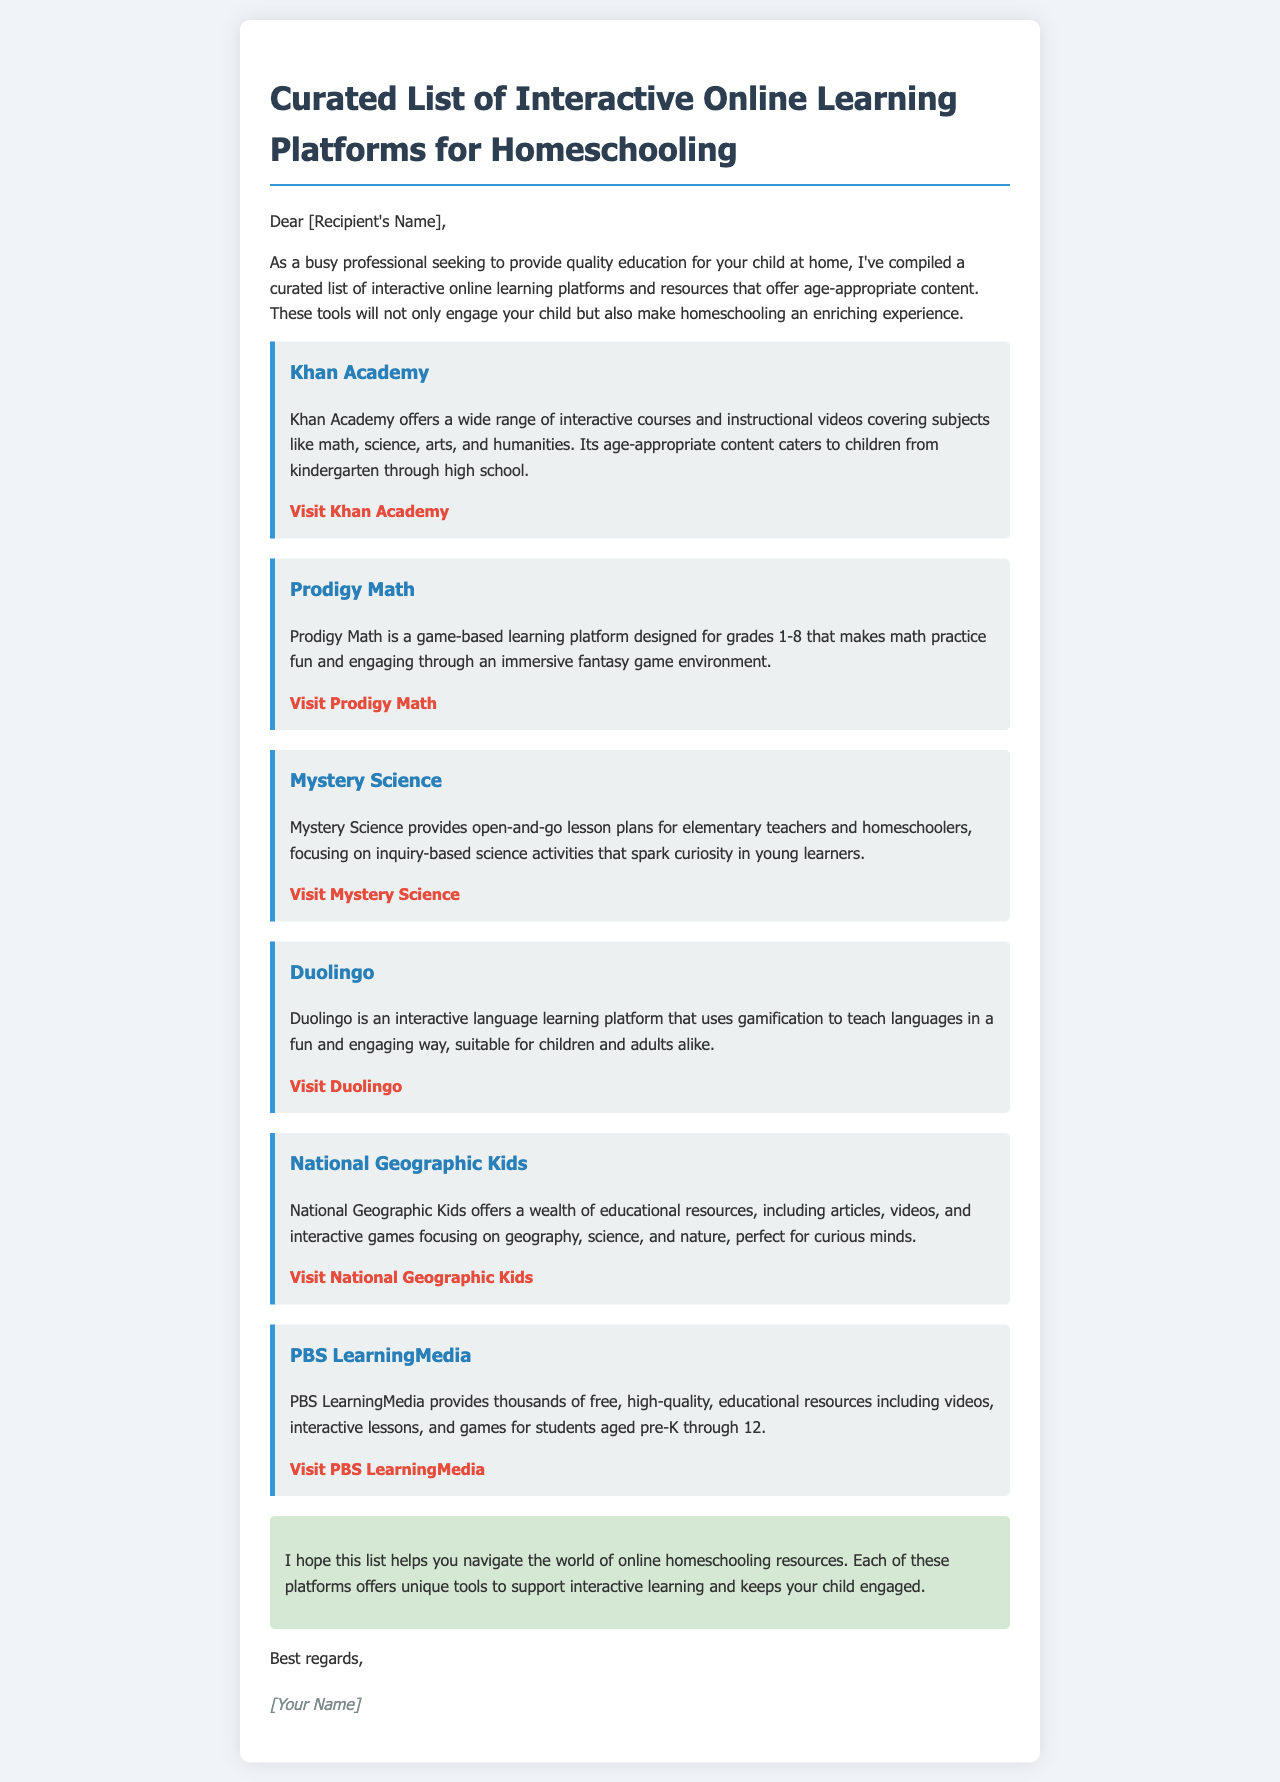What is the title of the document? The title of the document is found in the header section, which presents the main topic of the email.
Answer: Interactive Online Learning Platforms for Homeschooling How many online learning platforms are listed? The document contains six different online learning platforms and resources for homeschooling.
Answer: 6 What is the website for Khan Academy? The website provided for Khan Academy can be found in the resource section related to it.
Answer: https://www.khanacademy.org Which platform is focused on game-based learning? The document specifically mentions one platform that emphasizes a game-based learning approach for math.
Answer: Prodigy Math What age group does Mystery Science cater to? The document states that Mystery Science is specifically designed for elementary teachers and homeschoolers, indicating the educational level it targets.
Answer: Elementary Which platform uses gamification for language learning? The document identifies a specific platform that employs gamification as a method for teaching languages.
Answer: Duolingo What type of resources does PBS LearningMedia provide? The email outlines the types of materials available on PBS LearningMedia, describing them in broad categories.
Answer: Educational resources What is the main purpose of the email? The main purpose of the email is expressed in the opening paragraph, indicating the intent behind sharing the information.
Answer: To provide quality education resources for homeschooling 